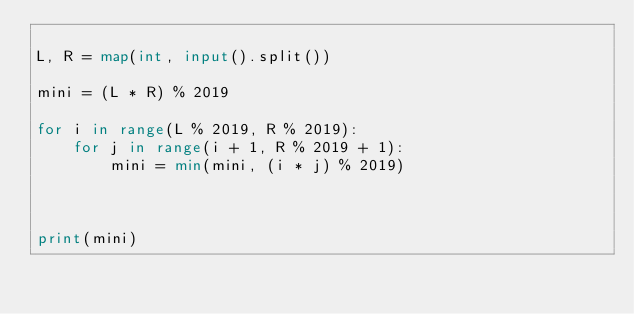<code> <loc_0><loc_0><loc_500><loc_500><_Python_>
L, R = map(int, input().split())

mini = (L * R) % 2019

for i in range(L % 2019, R % 2019):
    for j in range(i + 1, R % 2019 + 1):
        mini = min(mini, (i * j) % 2019)



print(mini)</code> 